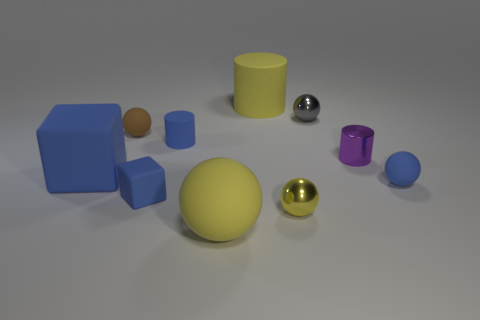What materials do the objects in this image appear to be made of? The objects present in the image exhibit a variety of textures suggesting different materials. The spheres and cylinders appear to have a glossy finish, implicating they could be made of polished metals or plastics. The blocks exhibit a more matte finish, resembling painted wood or matte plastic. 